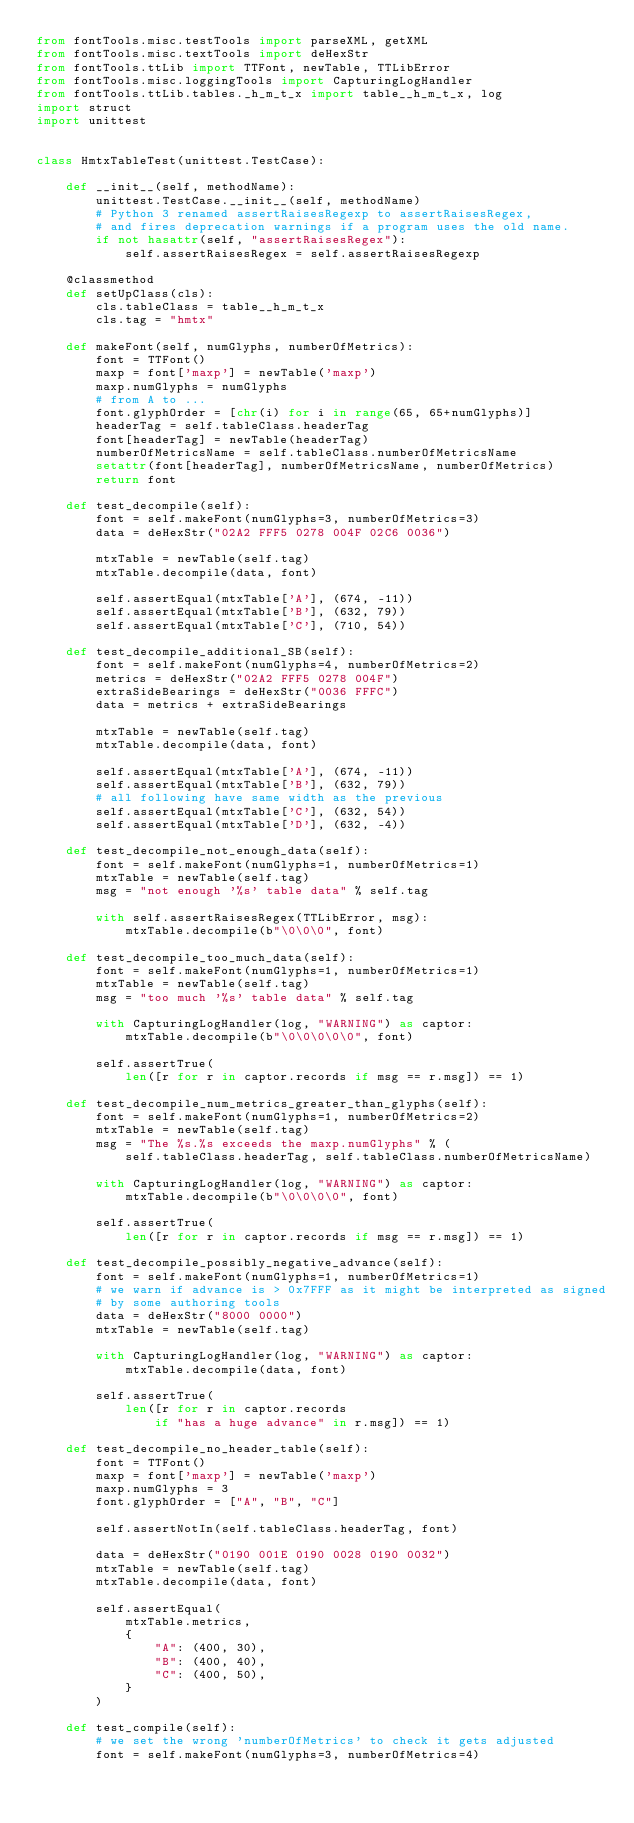Convert code to text. <code><loc_0><loc_0><loc_500><loc_500><_Python_>from fontTools.misc.testTools import parseXML, getXML
from fontTools.misc.textTools import deHexStr
from fontTools.ttLib import TTFont, newTable, TTLibError
from fontTools.misc.loggingTools import CapturingLogHandler
from fontTools.ttLib.tables._h_m_t_x import table__h_m_t_x, log
import struct
import unittest


class HmtxTableTest(unittest.TestCase):

    def __init__(self, methodName):
        unittest.TestCase.__init__(self, methodName)
        # Python 3 renamed assertRaisesRegexp to assertRaisesRegex,
        # and fires deprecation warnings if a program uses the old name.
        if not hasattr(self, "assertRaisesRegex"):
            self.assertRaisesRegex = self.assertRaisesRegexp

    @classmethod
    def setUpClass(cls):
        cls.tableClass = table__h_m_t_x
        cls.tag = "hmtx"

    def makeFont(self, numGlyphs, numberOfMetrics):
        font = TTFont()
        maxp = font['maxp'] = newTable('maxp')
        maxp.numGlyphs = numGlyphs
        # from A to ...
        font.glyphOrder = [chr(i) for i in range(65, 65+numGlyphs)]
        headerTag = self.tableClass.headerTag
        font[headerTag] = newTable(headerTag)
        numberOfMetricsName = self.tableClass.numberOfMetricsName
        setattr(font[headerTag], numberOfMetricsName, numberOfMetrics)
        return font

    def test_decompile(self):
        font = self.makeFont(numGlyphs=3, numberOfMetrics=3)
        data = deHexStr("02A2 FFF5 0278 004F 02C6 0036")

        mtxTable = newTable(self.tag)
        mtxTable.decompile(data, font)

        self.assertEqual(mtxTable['A'], (674, -11))
        self.assertEqual(mtxTable['B'], (632, 79))
        self.assertEqual(mtxTable['C'], (710, 54))

    def test_decompile_additional_SB(self):
        font = self.makeFont(numGlyphs=4, numberOfMetrics=2)
        metrics = deHexStr("02A2 FFF5 0278 004F")
        extraSideBearings = deHexStr("0036 FFFC")
        data = metrics + extraSideBearings

        mtxTable = newTable(self.tag)
        mtxTable.decompile(data, font)

        self.assertEqual(mtxTable['A'], (674, -11))
        self.assertEqual(mtxTable['B'], (632, 79))
        # all following have same width as the previous
        self.assertEqual(mtxTable['C'], (632, 54))
        self.assertEqual(mtxTable['D'], (632, -4))

    def test_decompile_not_enough_data(self):
        font = self.makeFont(numGlyphs=1, numberOfMetrics=1)
        mtxTable = newTable(self.tag)
        msg = "not enough '%s' table data" % self.tag

        with self.assertRaisesRegex(TTLibError, msg):
            mtxTable.decompile(b"\0\0\0", font)

    def test_decompile_too_much_data(self):
        font = self.makeFont(numGlyphs=1, numberOfMetrics=1)
        mtxTable = newTable(self.tag)
        msg = "too much '%s' table data" % self.tag

        with CapturingLogHandler(log, "WARNING") as captor:
            mtxTable.decompile(b"\0\0\0\0\0", font)

        self.assertTrue(
            len([r for r in captor.records if msg == r.msg]) == 1)

    def test_decompile_num_metrics_greater_than_glyphs(self):
        font = self.makeFont(numGlyphs=1, numberOfMetrics=2)
        mtxTable = newTable(self.tag)
        msg = "The %s.%s exceeds the maxp.numGlyphs" % (
            self.tableClass.headerTag, self.tableClass.numberOfMetricsName)

        with CapturingLogHandler(log, "WARNING") as captor:
            mtxTable.decompile(b"\0\0\0\0", font)

        self.assertTrue(
            len([r for r in captor.records if msg == r.msg]) == 1)

    def test_decompile_possibly_negative_advance(self):
        font = self.makeFont(numGlyphs=1, numberOfMetrics=1)
        # we warn if advance is > 0x7FFF as it might be interpreted as signed
        # by some authoring tools
        data = deHexStr("8000 0000")
        mtxTable = newTable(self.tag)

        with CapturingLogHandler(log, "WARNING") as captor:
            mtxTable.decompile(data, font)

        self.assertTrue(
            len([r for r in captor.records
                if "has a huge advance" in r.msg]) == 1)

    def test_decompile_no_header_table(self):
        font = TTFont()
        maxp = font['maxp'] = newTable('maxp')
        maxp.numGlyphs = 3
        font.glyphOrder = ["A", "B", "C"]

        self.assertNotIn(self.tableClass.headerTag, font)

        data = deHexStr("0190 001E 0190 0028 0190 0032")
        mtxTable = newTable(self.tag)
        mtxTable.decompile(data, font)

        self.assertEqual(
            mtxTable.metrics,
            {
                "A": (400, 30),
                "B": (400, 40),
                "C": (400, 50),
            }
        )

    def test_compile(self):
        # we set the wrong 'numberOfMetrics' to check it gets adjusted
        font = self.makeFont(numGlyphs=3, numberOfMetrics=4)</code> 